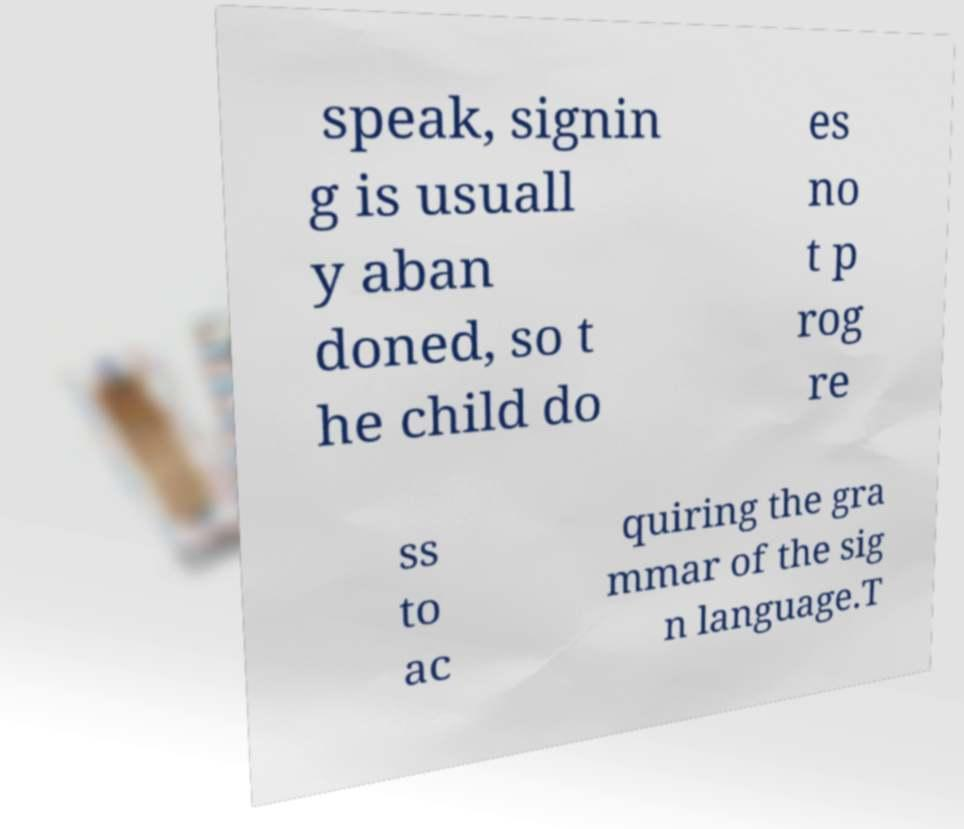For documentation purposes, I need the text within this image transcribed. Could you provide that? speak, signin g is usuall y aban doned, so t he child do es no t p rog re ss to ac quiring the gra mmar of the sig n language.T 